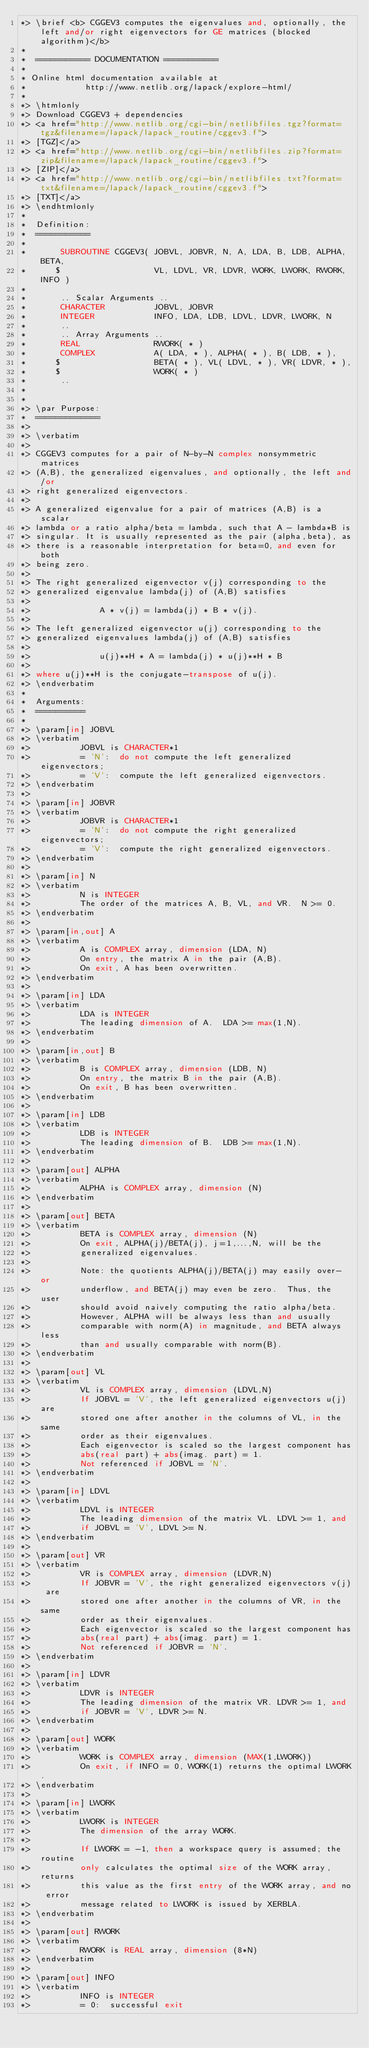<code> <loc_0><loc_0><loc_500><loc_500><_FORTRAN_>*> \brief <b> CGGEV3 computes the eigenvalues and, optionally, the left and/or right eigenvectors for GE matrices (blocked algorithm)</b>
*
*  =========== DOCUMENTATION ===========
*
* Online html documentation available at
*            http://www.netlib.org/lapack/explore-html/
*
*> \htmlonly
*> Download CGGEV3 + dependencies
*> <a href="http://www.netlib.org/cgi-bin/netlibfiles.tgz?format=tgz&filename=/lapack/lapack_routine/cggev3.f">
*> [TGZ]</a>
*> <a href="http://www.netlib.org/cgi-bin/netlibfiles.zip?format=zip&filename=/lapack/lapack_routine/cggev3.f">
*> [ZIP]</a>
*> <a href="http://www.netlib.org/cgi-bin/netlibfiles.txt?format=txt&filename=/lapack/lapack_routine/cggev3.f">
*> [TXT]</a>
*> \endhtmlonly
*
*  Definition:
*  ===========
*
*       SUBROUTINE CGGEV3( JOBVL, JOBVR, N, A, LDA, B, LDB, ALPHA, BETA,
*      $                   VL, LDVL, VR, LDVR, WORK, LWORK, RWORK, INFO )
*
*       .. Scalar Arguments ..
*       CHARACTER          JOBVL, JOBVR
*       INTEGER            INFO, LDA, LDB, LDVL, LDVR, LWORK, N
*       ..
*       .. Array Arguments ..
*       REAL               RWORK( * )
*       COMPLEX            A( LDA, * ), ALPHA( * ), B( LDB, * ),
*      $                   BETA( * ), VL( LDVL, * ), VR( LDVR, * ),
*      $                   WORK( * )
*       ..
*
*
*> \par Purpose:
*  =============
*>
*> \verbatim
*>
*> CGGEV3 computes for a pair of N-by-N complex nonsymmetric matrices
*> (A,B), the generalized eigenvalues, and optionally, the left and/or
*> right generalized eigenvectors.
*>
*> A generalized eigenvalue for a pair of matrices (A,B) is a scalar
*> lambda or a ratio alpha/beta = lambda, such that A - lambda*B is
*> singular. It is usually represented as the pair (alpha,beta), as
*> there is a reasonable interpretation for beta=0, and even for both
*> being zero.
*>
*> The right generalized eigenvector v(j) corresponding to the
*> generalized eigenvalue lambda(j) of (A,B) satisfies
*>
*>              A * v(j) = lambda(j) * B * v(j).
*>
*> The left generalized eigenvector u(j) corresponding to the
*> generalized eigenvalues lambda(j) of (A,B) satisfies
*>
*>              u(j)**H * A = lambda(j) * u(j)**H * B
*>
*> where u(j)**H is the conjugate-transpose of u(j).
*> \endverbatim
*
*  Arguments:
*  ==========
*
*> \param[in] JOBVL
*> \verbatim
*>          JOBVL is CHARACTER*1
*>          = 'N':  do not compute the left generalized eigenvectors;
*>          = 'V':  compute the left generalized eigenvectors.
*> \endverbatim
*>
*> \param[in] JOBVR
*> \verbatim
*>          JOBVR is CHARACTER*1
*>          = 'N':  do not compute the right generalized eigenvectors;
*>          = 'V':  compute the right generalized eigenvectors.
*> \endverbatim
*>
*> \param[in] N
*> \verbatim
*>          N is INTEGER
*>          The order of the matrices A, B, VL, and VR.  N >= 0.
*> \endverbatim
*>
*> \param[in,out] A
*> \verbatim
*>          A is COMPLEX array, dimension (LDA, N)
*>          On entry, the matrix A in the pair (A,B).
*>          On exit, A has been overwritten.
*> \endverbatim
*>
*> \param[in] LDA
*> \verbatim
*>          LDA is INTEGER
*>          The leading dimension of A.  LDA >= max(1,N).
*> \endverbatim
*>
*> \param[in,out] B
*> \verbatim
*>          B is COMPLEX array, dimension (LDB, N)
*>          On entry, the matrix B in the pair (A,B).
*>          On exit, B has been overwritten.
*> \endverbatim
*>
*> \param[in] LDB
*> \verbatim
*>          LDB is INTEGER
*>          The leading dimension of B.  LDB >= max(1,N).
*> \endverbatim
*>
*> \param[out] ALPHA
*> \verbatim
*>          ALPHA is COMPLEX array, dimension (N)
*> \endverbatim
*>
*> \param[out] BETA
*> \verbatim
*>          BETA is COMPLEX array, dimension (N)
*>          On exit, ALPHA(j)/BETA(j), j=1,...,N, will be the
*>          generalized eigenvalues.
*>
*>          Note: the quotients ALPHA(j)/BETA(j) may easily over- or
*>          underflow, and BETA(j) may even be zero.  Thus, the user
*>          should avoid naively computing the ratio alpha/beta.
*>          However, ALPHA will be always less than and usually
*>          comparable with norm(A) in magnitude, and BETA always less
*>          than and usually comparable with norm(B).
*> \endverbatim
*>
*> \param[out] VL
*> \verbatim
*>          VL is COMPLEX array, dimension (LDVL,N)
*>          If JOBVL = 'V', the left generalized eigenvectors u(j) are
*>          stored one after another in the columns of VL, in the same
*>          order as their eigenvalues.
*>          Each eigenvector is scaled so the largest component has
*>          abs(real part) + abs(imag. part) = 1.
*>          Not referenced if JOBVL = 'N'.
*> \endverbatim
*>
*> \param[in] LDVL
*> \verbatim
*>          LDVL is INTEGER
*>          The leading dimension of the matrix VL. LDVL >= 1, and
*>          if JOBVL = 'V', LDVL >= N.
*> \endverbatim
*>
*> \param[out] VR
*> \verbatim
*>          VR is COMPLEX array, dimension (LDVR,N)
*>          If JOBVR = 'V', the right generalized eigenvectors v(j) are
*>          stored one after another in the columns of VR, in the same
*>          order as their eigenvalues.
*>          Each eigenvector is scaled so the largest component has
*>          abs(real part) + abs(imag. part) = 1.
*>          Not referenced if JOBVR = 'N'.
*> \endverbatim
*>
*> \param[in] LDVR
*> \verbatim
*>          LDVR is INTEGER
*>          The leading dimension of the matrix VR. LDVR >= 1, and
*>          if JOBVR = 'V', LDVR >= N.
*> \endverbatim
*>
*> \param[out] WORK
*> \verbatim
*>          WORK is COMPLEX array, dimension (MAX(1,LWORK))
*>          On exit, if INFO = 0, WORK(1) returns the optimal LWORK.
*> \endverbatim
*>
*> \param[in] LWORK
*> \verbatim
*>          LWORK is INTEGER
*>          The dimension of the array WORK.
*>
*>          If LWORK = -1, then a workspace query is assumed; the routine
*>          only calculates the optimal size of the WORK array, returns
*>          this value as the first entry of the WORK array, and no error
*>          message related to LWORK is issued by XERBLA.
*> \endverbatim
*>
*> \param[out] RWORK
*> \verbatim
*>          RWORK is REAL array, dimension (8*N)
*> \endverbatim
*>
*> \param[out] INFO
*> \verbatim
*>          INFO is INTEGER
*>          = 0:  successful exit</code> 